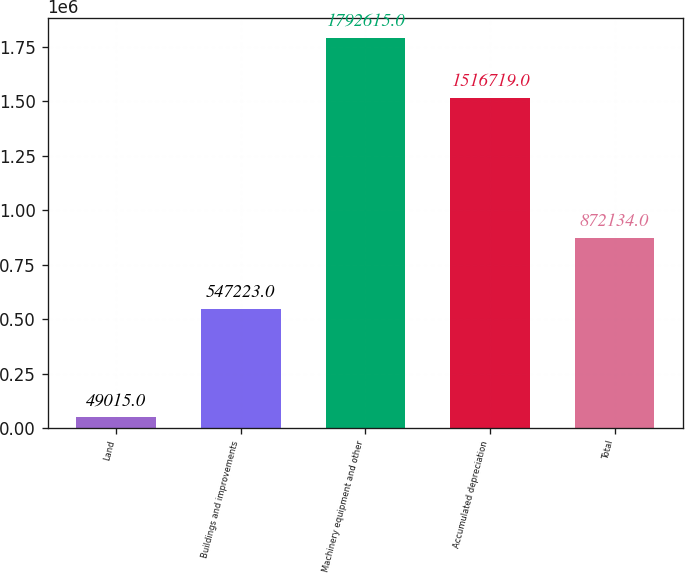Convert chart. <chart><loc_0><loc_0><loc_500><loc_500><bar_chart><fcel>Land<fcel>Buildings and improvements<fcel>Machinery equipment and other<fcel>Accumulated depreciation<fcel>Total<nl><fcel>49015<fcel>547223<fcel>1.79262e+06<fcel>1.51672e+06<fcel>872134<nl></chart> 